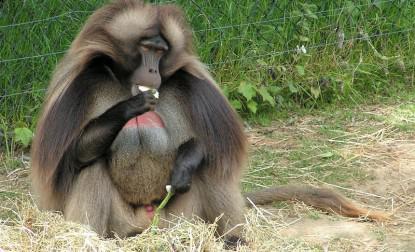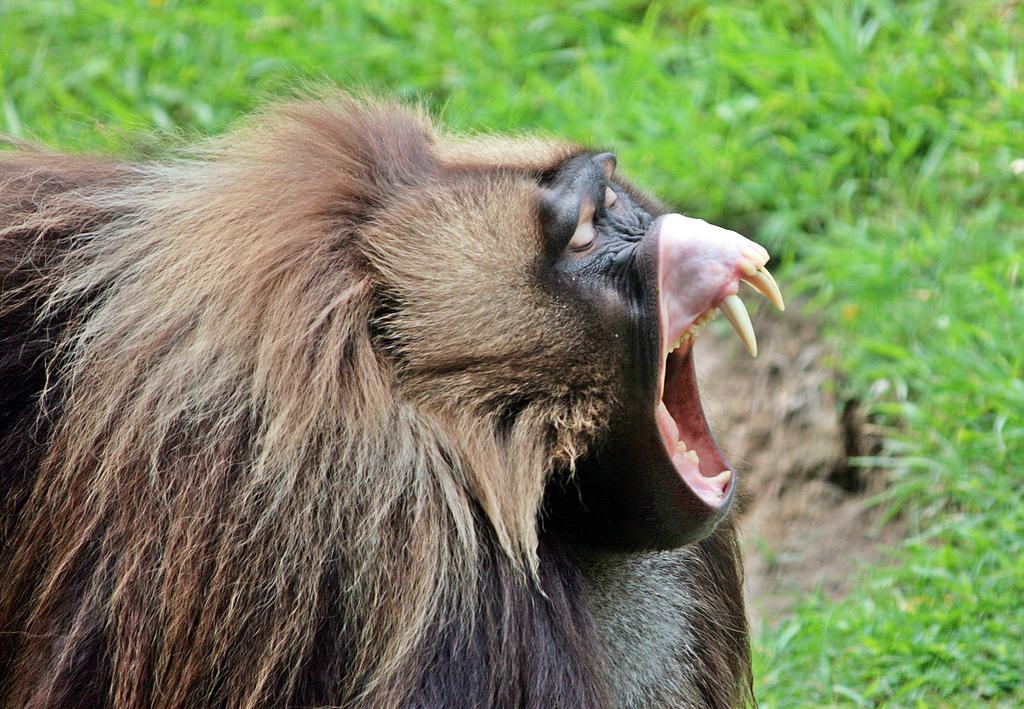The first image is the image on the left, the second image is the image on the right. For the images shown, is this caption "in the right pic the fangs of the monkey is shown" true? Answer yes or no. Yes. The first image is the image on the left, the second image is the image on the right. For the images displayed, is the sentence "There is a total of 1 baboon eating while sitting down." factually correct? Answer yes or no. Yes. 